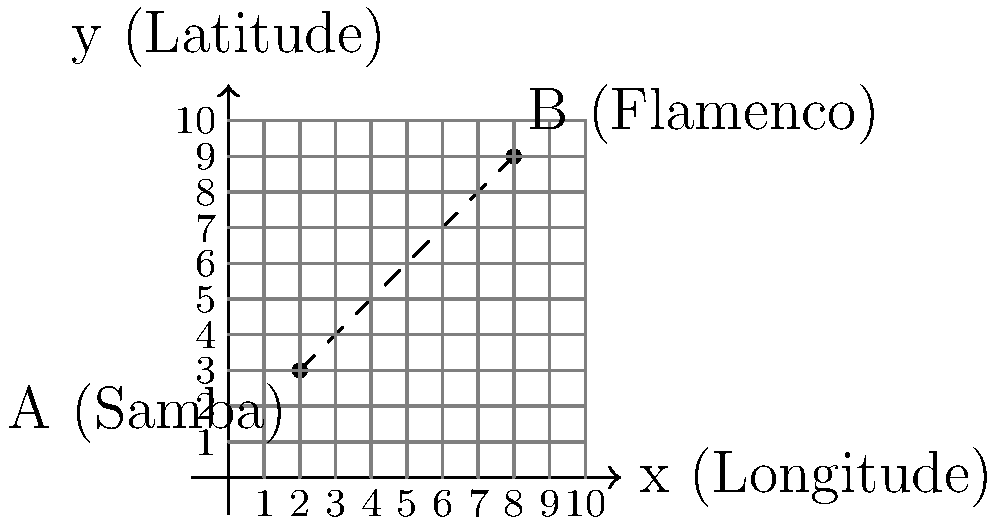As a language student exploring world music, you're studying the geographical origins of different genres. On a map, the coordinates of two music genres are given: Samba (from Brazil) at point A(2, 3) and Flamenco (from Spain) at point B(8, 9). Calculate the distance between these two points to understand the geographical spread of these genres. Use the distance formula: $d = \sqrt{(x_2 - x_1)^2 + (y_2 - y_1)^2}$. Round your answer to two decimal places. To find the distance between two points, we'll use the distance formula:

$d = \sqrt{(x_2 - x_1)^2 + (y_2 - y_1)^2}$

Where:
$(x_1, y_1)$ is the coordinate of point A (Samba): (2, 3)
$(x_2, y_2)$ is the coordinate of point B (Flamenco): (8, 9)

Let's substitute these values into the formula:

$d = \sqrt{(8 - 2)^2 + (9 - 3)^2}$

Now, let's solve step by step:

1. Calculate the differences:
   $d = \sqrt{(6)^2 + (6)^2}$

2. Square the differences:
   $d = \sqrt{36 + 36}$

3. Add the squared differences:
   $d = \sqrt{72}$

4. Calculate the square root:
   $d = \sqrt{72} \approx 8.4853$

5. Round to two decimal places:
   $d \approx 8.49$

Therefore, the distance between the origins of Samba and Flamenco on our map is approximately 8.49 units.
Answer: 8.49 units 